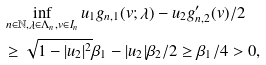<formula> <loc_0><loc_0><loc_500><loc_500>& \inf _ { n \in \mathbb { N } , \lambda \in \Lambda _ { n } , v \in I _ { n } } u _ { 1 } g _ { n , 1 } ( v ; \lambda ) - u _ { 2 } g ^ { \prime } _ { n , 2 } ( v ) / 2 \\ & \geq \sqrt { 1 - | u _ { 2 } | ^ { 2 } } \beta _ { 1 } - | u _ { 2 } | \beta _ { 2 } / 2 \geq \beta _ { 1 } / 4 > 0 ,</formula> 